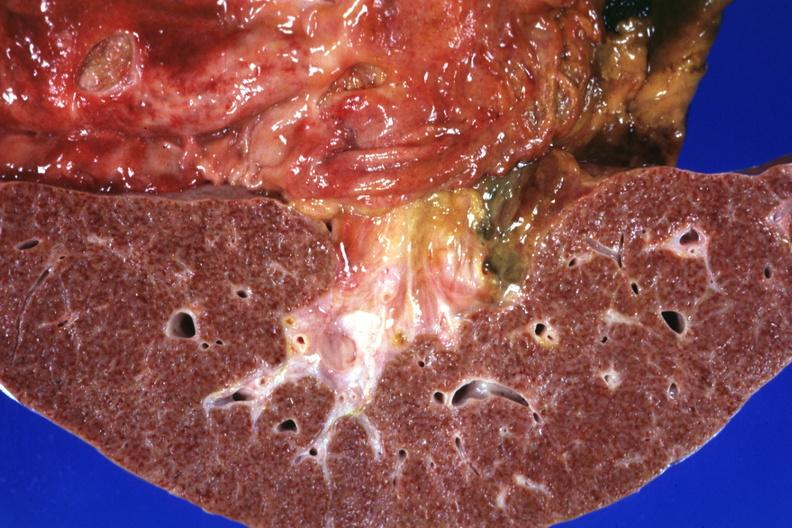what shows gastric and duodenal ulcers?
Answer the question using a single word or phrase. This frontal section micronodular photo 